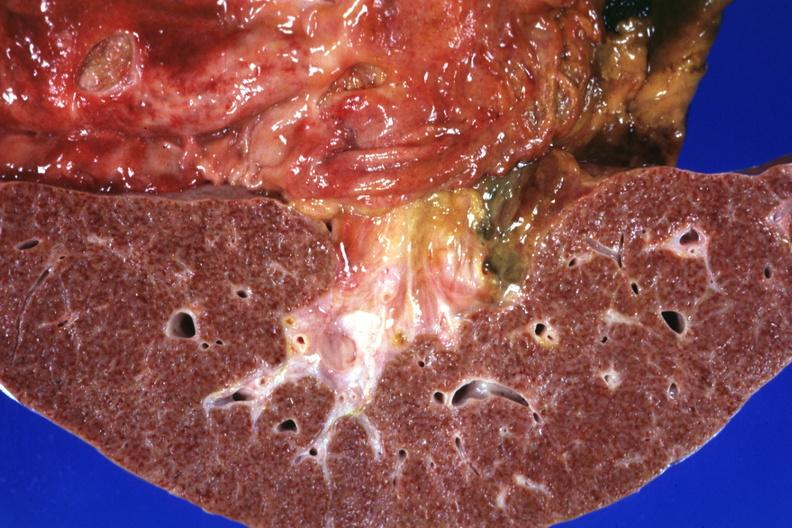what shows gastric and duodenal ulcers?
Answer the question using a single word or phrase. This frontal section micronodular photo 